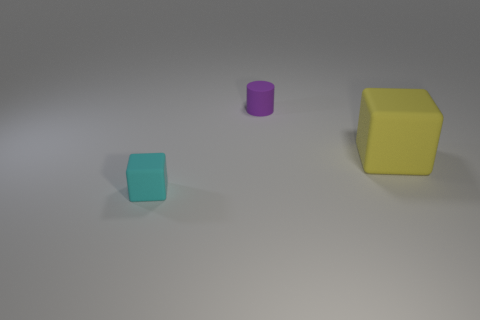What material is the cube that is the same size as the purple matte cylinder?
Provide a succinct answer. Rubber. Is there a red block made of the same material as the tiny purple thing?
Your answer should be very brief. No. What is the color of the thing that is to the right of the small block and in front of the tiny purple object?
Your answer should be compact. Yellow. How many other objects are the same color as the cylinder?
Your answer should be very brief. 0. What material is the small thing behind the tiny object that is in front of the purple rubber object behind the small cyan rubber thing?
Give a very brief answer. Rubber. How many balls are yellow rubber objects or purple matte objects?
Keep it short and to the point. 0. Is there any other thing that has the same size as the yellow object?
Provide a succinct answer. No. How many yellow blocks are behind the small object behind the tiny rubber object that is in front of the small purple object?
Make the answer very short. 0. Do the big matte object and the tiny cyan thing have the same shape?
Your answer should be compact. Yes. Is the small object in front of the small purple object made of the same material as the large cube right of the purple object?
Your answer should be very brief. Yes. 